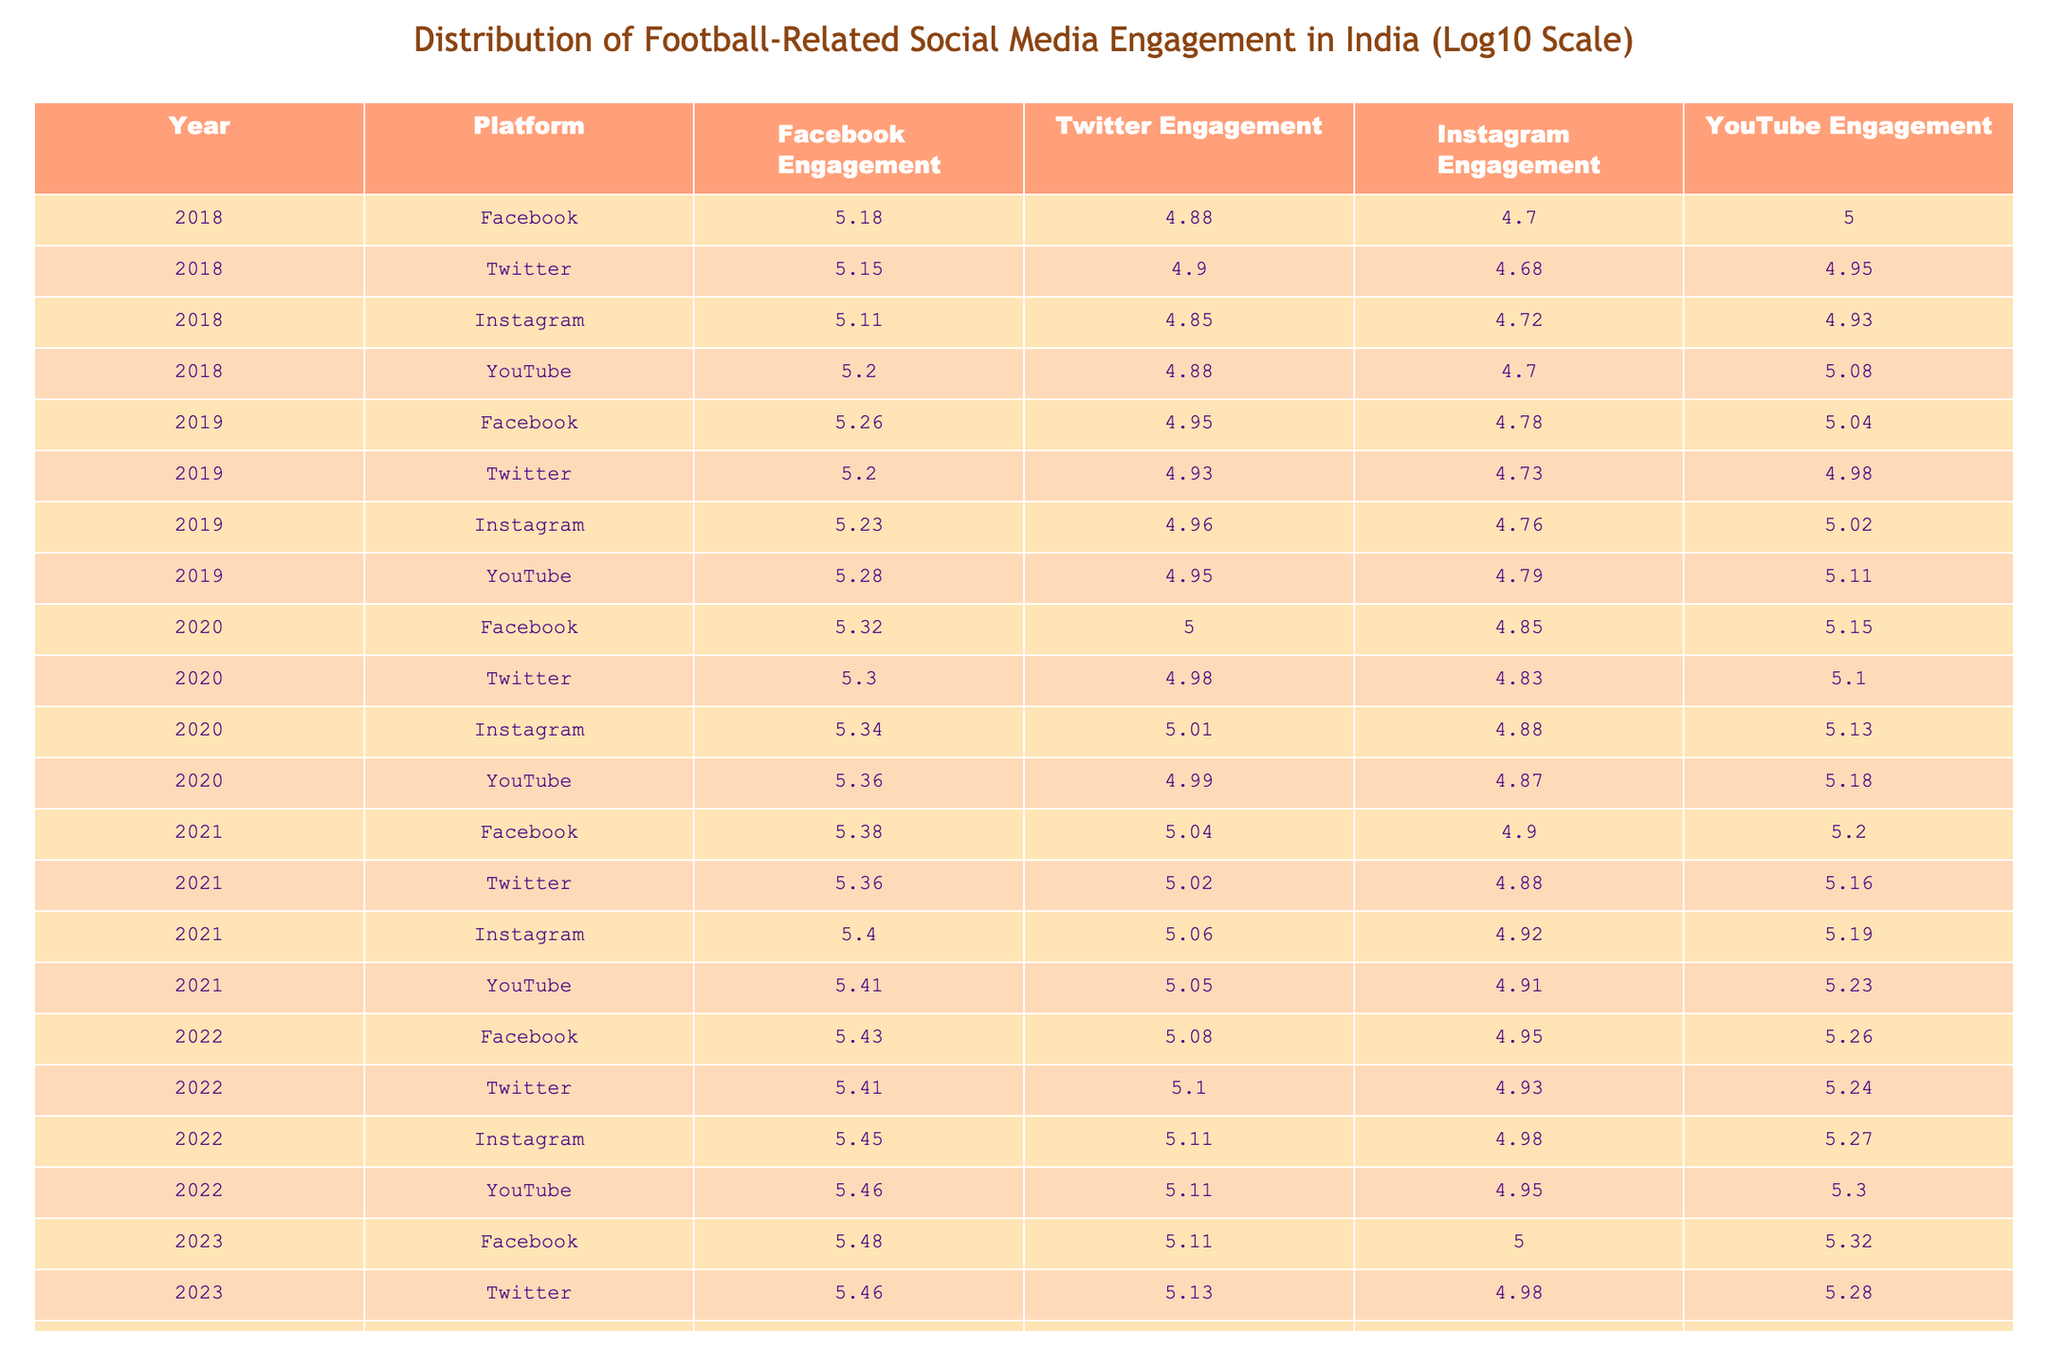What was the highest Instagram engagement recorded in 2023? In 2023, the table indicates that Instagram engagement was at a value of 310000. This value can be found directly under the Instagram Engagement column for the year 2023.
Answer: 310000 What year saw the highest Twitter engagement? By observing the Twitter Engagement column across all years, in 2022, the highest Twitter engagement recorded was 135000. The other years show lower values, making 2022 the year with the highest Twitter engagement.
Answer: 2022 What is the average Facebook engagement from 2018 to 2023? The values for Facebook Engagement from 2018 to 2023 are 150000, 180000, 210000, 240000, 270000, and 300000. To find the average, first sum these values (150000 + 180000 + 210000 + 240000 + 270000 + 300000 = 1350000). Then, divide by the number of years (6): 1350000 / 6 = 225000.
Answer: 225000 Did YouTube engagement increase every year from 2018 to 2023? By examining the YouTube Engagement column for each year consecutively, we find the following values: 100000 (2018), 110000 (2019), 140000 (2020), 160000 (2021), 180000 (2022), and 210000 (2023). Each subsequent year shows an increase, confirming that YouTube engagement did indeed rise every year.
Answer: Yes What is the difference in Facebook engagement between 2023 and 2020? The Facebook engagement for 2023 is 300000 and for 2020 it is 210000. To find the difference, subtract the 2020 value from the 2023 value: 300000 - 210000 = 90000. Therefore, the difference in engagement is 90000.
Answer: 90000 